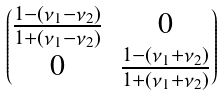Convert formula to latex. <formula><loc_0><loc_0><loc_500><loc_500>\begin{pmatrix} \frac { 1 - ( \nu _ { 1 } - \nu _ { 2 } ) } { 1 + ( \nu _ { 1 } - \nu _ { 2 } ) } & 0 \\ 0 & \frac { 1 - ( \nu _ { 1 } + \nu _ { 2 } ) } { 1 + ( \nu _ { 1 } + \nu _ { 2 } ) } \end{pmatrix}</formula> 